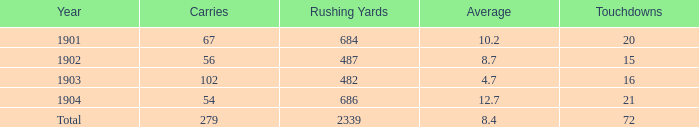How many carries have an average under 8.7 and touchdowns of 72? 1.0. 